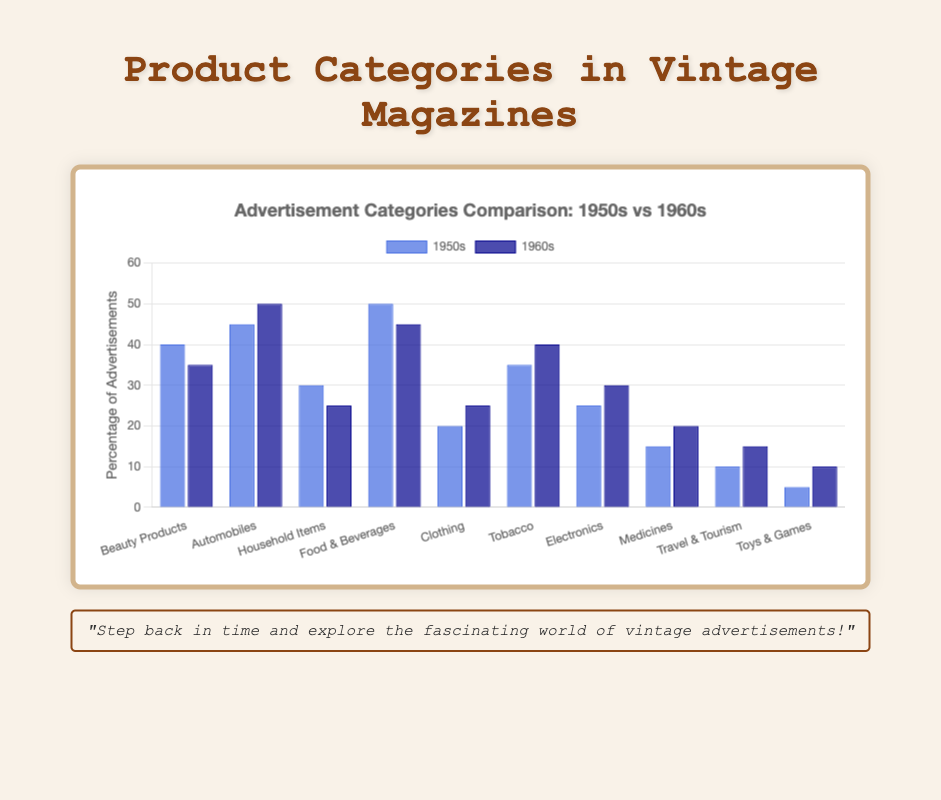Which product category had the highest percentage of advertisements in the 1950s? The chart shows the blue bar representing the 1950s highest for "Food & Beverages" at 50%.
Answer: Food & Beverages In which product category did the percentage of advertisements increase from the 1950s to the 1960s? Compare the height of the blue bar (1950s) to the dark blue bar (1960s). For "Automobiles", "Clothing", "Tobacco", "Electronics", "Medicines", "Travel & Tourism", and "Toys & Games", the percentage increased.
Answer: Automobiles, Clothing, Tobacco, Electronics, Medicines, Travel & Tourism, Toys & Games What was the total percentage of advertisements for "Household Items" and "Beauty Products" in the 1950s? Add the blue bars for "Household Items" (30%) and "Beauty Products" (40%).
Answer: 70% Which two product categories had a decrease in the percentage of advertisements from the 1950s to the 1960s? Identify bars where the blue (1950s) is higher than the dark blue (1960s). "Beauty Products" and "Household Items" show a decrease.
Answer: Beauty Products, Household Items What percentage of advertisements were for "Electronics" in both the 1950s and 1960s? Check the blue bar (1950s) and dark blue bar (1960s) for "Electronics". They are 25% and 30% respectively.
Answer: 25%, 30% What is the difference in the percentage of "Tobacco" advertisements between the 1950s and 1960s? Subtract the blue bar (1950s, 35%) from the dark blue bar (1960s, 40%).
Answer: 5% Which product category had the least percentage of advertisements in the 1960s? The shortest dark blue bar represents "Toys & Games" at 10%.
Answer: Toys & Games What is the average percentage of advertisements for "Beauty Products", "Automobiles", and "Food & Beverages" in the 1960s? Add the dark blue bars for those categories (35% + 50% + 45%) and divide by 3.
Answer: 43.33% By how many percentage points did "Travel & Tourism" advertisements increase from the 1950s to the 1960s? Subtract the blue bar (1950s, 10%) from the dark blue bar (1960s, 15%).
Answer: 5% 